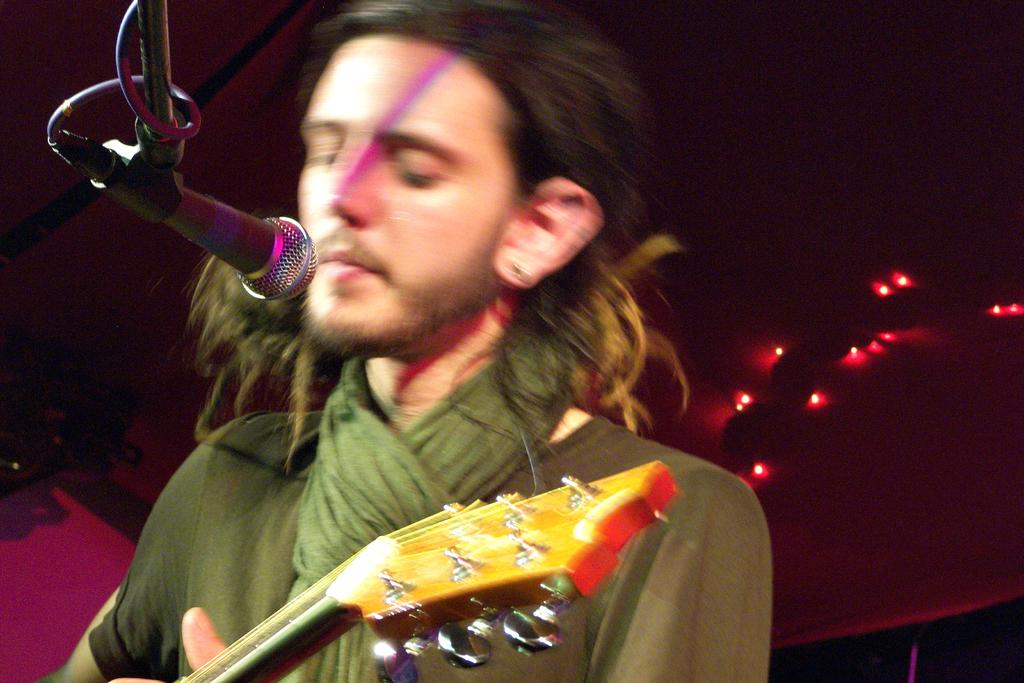Who or what is in the image? There is a person in the image. What is the person holding in the image? The person is holding a microphone. Is there another microphone in the image? Yes, there is a microphone in front of the person. What can be seen behind the person in the image? There are lights visible behind the person. How many geese are visible in the image? There are no geese present in the image. What type of dirt is being used to clean the microphone in the image? There is no dirt or cleaning activity involving the microphone in the image. 